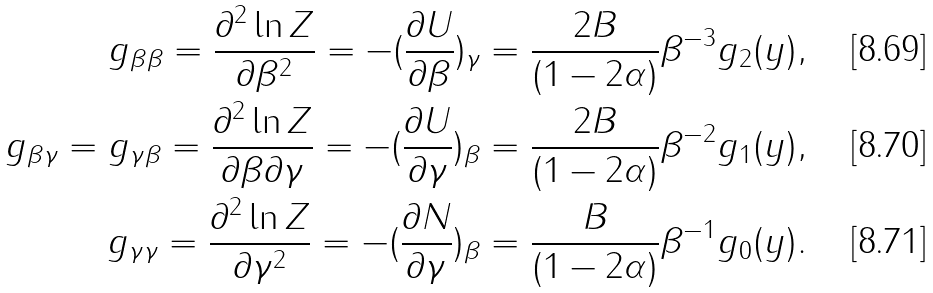<formula> <loc_0><loc_0><loc_500><loc_500>g _ { \beta \beta } = \frac { \partial ^ { 2 } \ln Z } { \partial \beta ^ { 2 } } = - ( \frac { \partial U } { \partial \beta } ) _ { \gamma } = \frac { 2 B } { ( 1 - 2 \alpha ) } \beta ^ { - 3 } g _ { 2 } ( y ) , \\ g _ { \beta \gamma } = g _ { \gamma \beta } = \frac { \partial ^ { 2 } \ln Z } { \partial \beta \partial \gamma } = - ( \frac { \partial U } { \partial \gamma } ) _ { \beta } = \frac { 2 B } { ( 1 - 2 \alpha ) } \beta ^ { - 2 } g _ { 1 } ( y ) , \\ g _ { \gamma \gamma } = \frac { \partial ^ { 2 } \ln Z } { \partial \gamma ^ { 2 } } = - ( \frac { \partial N } { \partial \gamma } ) _ { \beta } = \frac { B } { ( 1 - 2 \alpha ) } \beta ^ { - 1 } g _ { 0 } ( y ) .</formula> 